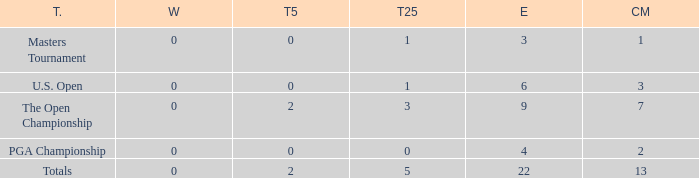What is the total number of wins for events with under 2 top-5s, under 5 top-25s, and more than 4 events played? 1.0. 